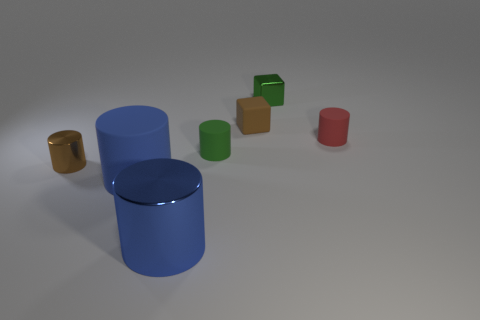Add 2 red rubber cubes. How many objects exist? 9 Subtract all cylinders. How many objects are left? 2 Subtract all tiny brown shiny cylinders. How many cylinders are left? 4 Subtract 1 blocks. How many blocks are left? 1 Subtract all big objects. Subtract all green matte cylinders. How many objects are left? 4 Add 3 brown metal cylinders. How many brown metal cylinders are left? 4 Add 1 small red things. How many small red things exist? 2 Subtract all brown blocks. How many blocks are left? 1 Subtract 1 green cylinders. How many objects are left? 6 Subtract all gray cylinders. Subtract all blue blocks. How many cylinders are left? 5 